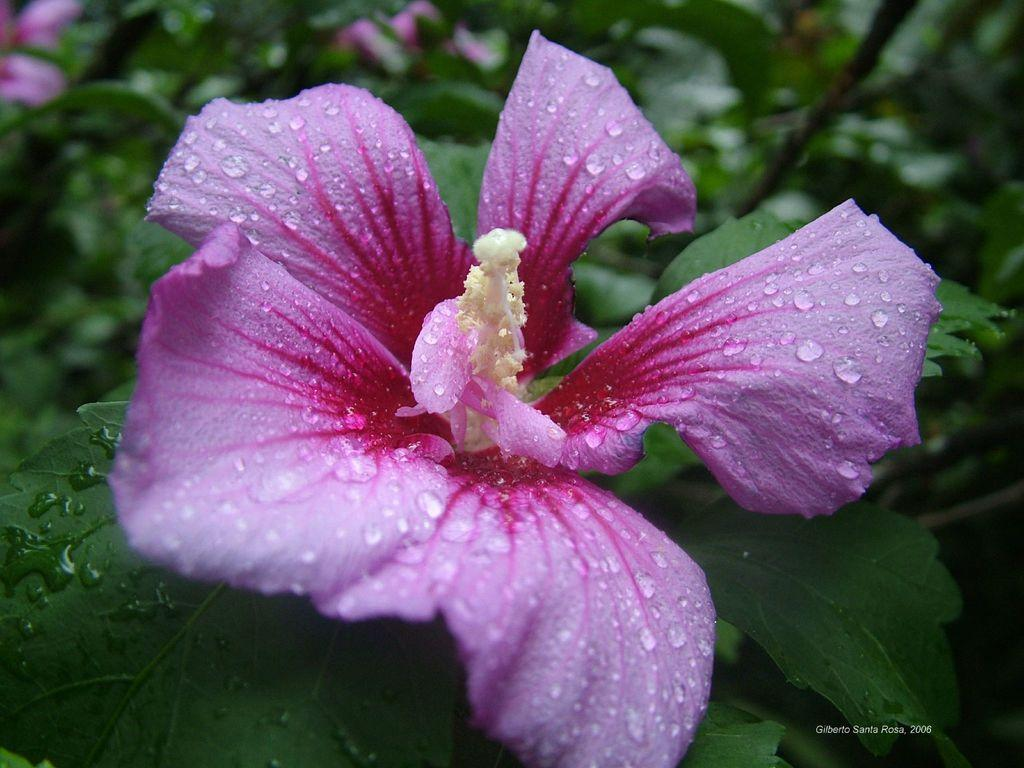What is present in the foreground of the image? There are droplets on a flower in the foreground. What can be found at the bottom of the image? There is text at the bottom side of the image. What type of vegetation is visible in the background of the image? There are leaves in the background of the image. How much dust can be seen on the flower in the image? There is no mention of dust in the image, so it cannot be determined how much dust is present. What type of liquid is visible on the flower in the image? The image only mentions droplets on the flower, not a specific liquid, so it cannot be determined what type of liquid is present. 